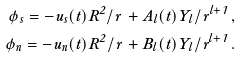Convert formula to latex. <formula><loc_0><loc_0><loc_500><loc_500>\phi _ { s } = - u _ { s } ( t ) R ^ { 2 } / r \, + A _ { l } ( t ) Y _ { l } / r ^ { l + 1 } \, , \\ \phi _ { n } = - u _ { n } ( t ) R ^ { 2 } / r \, + B _ { l } ( t ) Y _ { l } / r ^ { l + 1 } \, .</formula> 